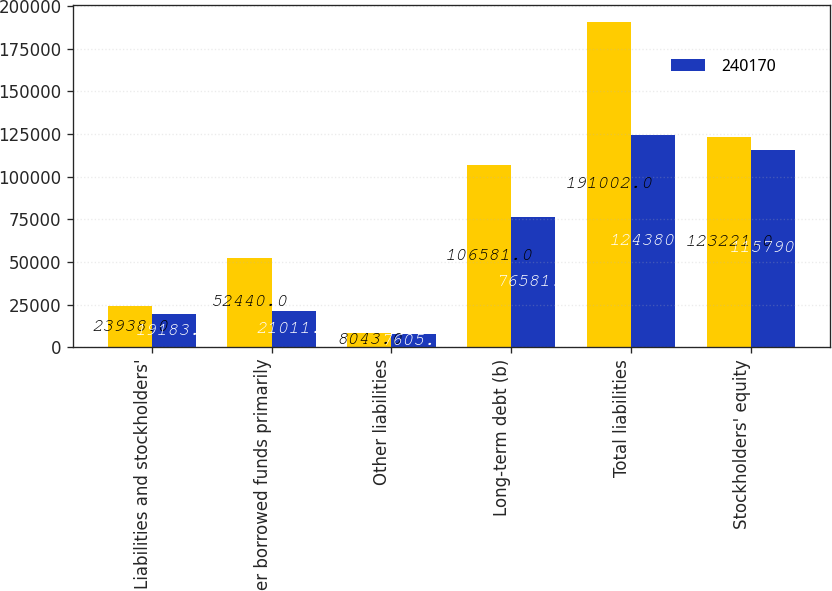Convert chart. <chart><loc_0><loc_0><loc_500><loc_500><stacked_bar_chart><ecel><fcel>Liabilities and stockholders'<fcel>Other borrowed funds primarily<fcel>Other liabilities<fcel>Long-term debt (b)<fcel>Total liabilities<fcel>Stockholders' equity<nl><fcel>nan<fcel>23938<fcel>52440<fcel>8043<fcel>106581<fcel>191002<fcel>123221<nl><fcel>240170<fcel>19183<fcel>21011<fcel>7605<fcel>76581<fcel>124380<fcel>115790<nl></chart> 